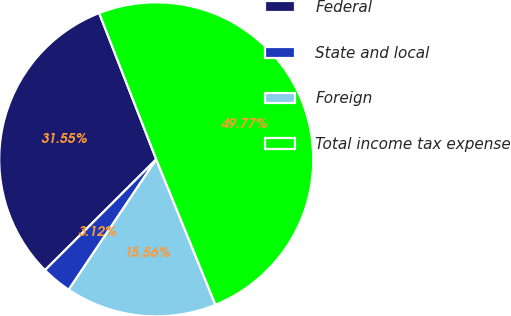<chart> <loc_0><loc_0><loc_500><loc_500><pie_chart><fcel>Federal<fcel>State and local<fcel>Foreign<fcel>Total income tax expense<nl><fcel>31.55%<fcel>3.12%<fcel>15.56%<fcel>49.77%<nl></chart> 